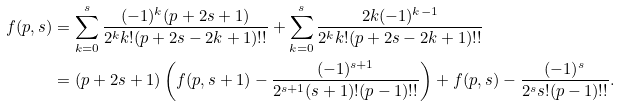Convert formula to latex. <formula><loc_0><loc_0><loc_500><loc_500>f ( p , s ) & = \sum _ { k = 0 } ^ { s } \frac { ( - 1 ) ^ { k } ( p + 2 s + 1 ) } { 2 ^ { k } k ! ( p + 2 s - 2 k + 1 ) ! ! } + \sum _ { k = 0 } ^ { s } \frac { 2 k ( - 1 ) ^ { k - 1 } } { 2 ^ { k } k ! ( p + 2 s - 2 k + 1 ) ! ! } \\ & = ( p + 2 s + 1 ) \left ( f ( p , s + 1 ) - \frac { ( - 1 ) ^ { s + 1 } } { 2 ^ { s + 1 } ( s + 1 ) ! ( p - 1 ) ! ! } \right ) + f ( p , s ) - \frac { ( - 1 ) ^ { s } } { 2 ^ { s } s ! ( p - 1 ) ! ! } .</formula> 